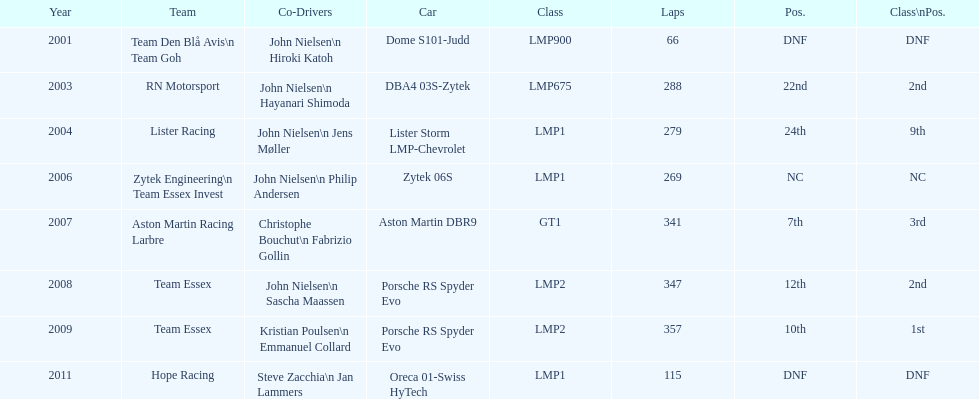Who was casper elgaard's most frequent co-driver for the 24 hours of le mans? John Nielsen. 